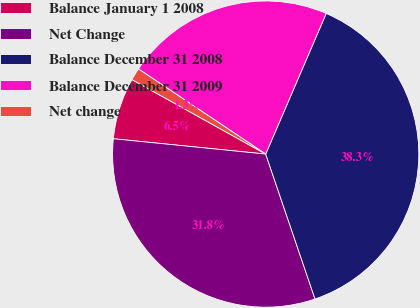Convert chart to OTSL. <chart><loc_0><loc_0><loc_500><loc_500><pie_chart><fcel>Balance January 1 2008<fcel>Net Change<fcel>Balance December 31 2008<fcel>Balance December 31 2009<fcel>Net change<nl><fcel>6.49%<fcel>31.82%<fcel>38.31%<fcel>22.08%<fcel>1.3%<nl></chart> 